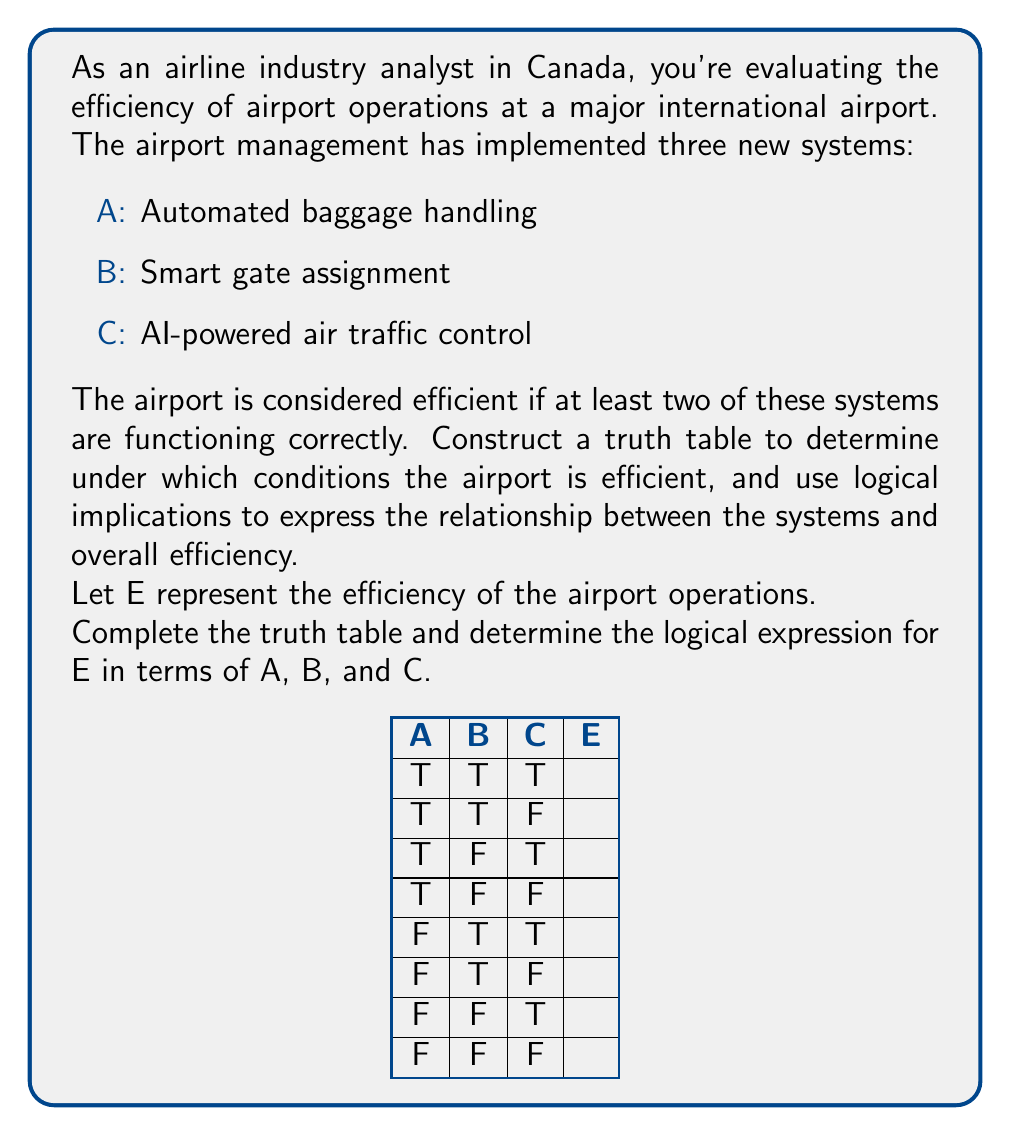Solve this math problem. To solve this problem, we'll follow these steps:

1. Complete the truth table
2. Determine the logical expression for E
3. Simplify the expression if possible

Step 1: Completing the truth table

The airport is efficient (E is true) when at least two of the systems (A, B, C) are functioning correctly (true). Let's complete the truth table:

[asy]
unitsize(30);
defaultpen(fontsize(10pt));

string[] headers = {"A", "B", "C", "E"};
for (int i = 0; i < 4; ++i) {
  label(headers[i], (-1.5, 3.5-i));
}

string[][] values = {
  {"T", "T", "T", "T"},
  {"T", "T", "F", "T"},
  {"T", "F", "T", "T"},
  {"T", "F", "F", "F"},
  {"F", "T", "T", "T"},
  {"F", "T", "F", "F"},
  {"F", "F", "T", "F"},
  {"F", "F", "F", "F"}
};

for (int i = 0; i < 8; ++i) {
  for (int j = 0; j < 4; ++j) {
    label(values[i][j], (j, 3.5-i/2));
  }
}

for (int i = -2; i <= 3; ++i) {
  draw((-2,i)--(3,i));
}
for (int i = -1; i <= 3; ++i) {
  draw((i,-1)--(i,4));
}
[/asy]

Step 2: Determining the logical expression for E

Looking at the truth table, we can express E as a logical combination of A, B, and C. E is true when:
- All three systems are functioning (A ∧ B ∧ C), or
- Any two systems are functioning: (A ∧ B ∧ ¬C) ∨ (A ∧ ¬B ∧ C) ∨ (¬A ∧ B ∧ C)

We can express this as:

$$ E = (A \land B \land C) \lor (A \land B \land \lnot C) \lor (A \land \lnot B \land C) \lor (\lnot A \land B \land C) $$

Step 3: Simplifying the expression

We can simplify this expression using logical equivalences:

$$ \begin{align*}
E &= (A \land B \land C) \lor (A \land B \land \lnot C) \lor (A \land \lnot B \land C) \lor (\lnot A \land B \land C) \\
&= (A \land B) \lor (A \land C) \lor (B \land C)
\end{align*} $$

This simplified expression represents that the airport is efficient when at least two of the three systems are functioning.

Using logical implication, we can express this as:

$$ ((A \land B) \lor (A \land C) \lor (B \land C)) \rightarrow E $$

This means that if at least two systems are functioning, then the airport operations are efficient.
Answer: $E = (A \land B) \lor (A \land C) \lor (B \land C)$ 